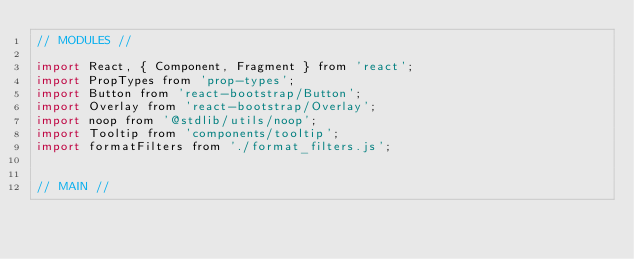Convert code to text. <code><loc_0><loc_0><loc_500><loc_500><_JavaScript_>// MODULES //

import React, { Component, Fragment } from 'react';
import PropTypes from 'prop-types';
import Button from 'react-bootstrap/Button';
import Overlay from 'react-bootstrap/Overlay';
import noop from '@stdlib/utils/noop';
import Tooltip from 'components/tooltip';
import formatFilters from './format_filters.js';


// MAIN //
</code> 